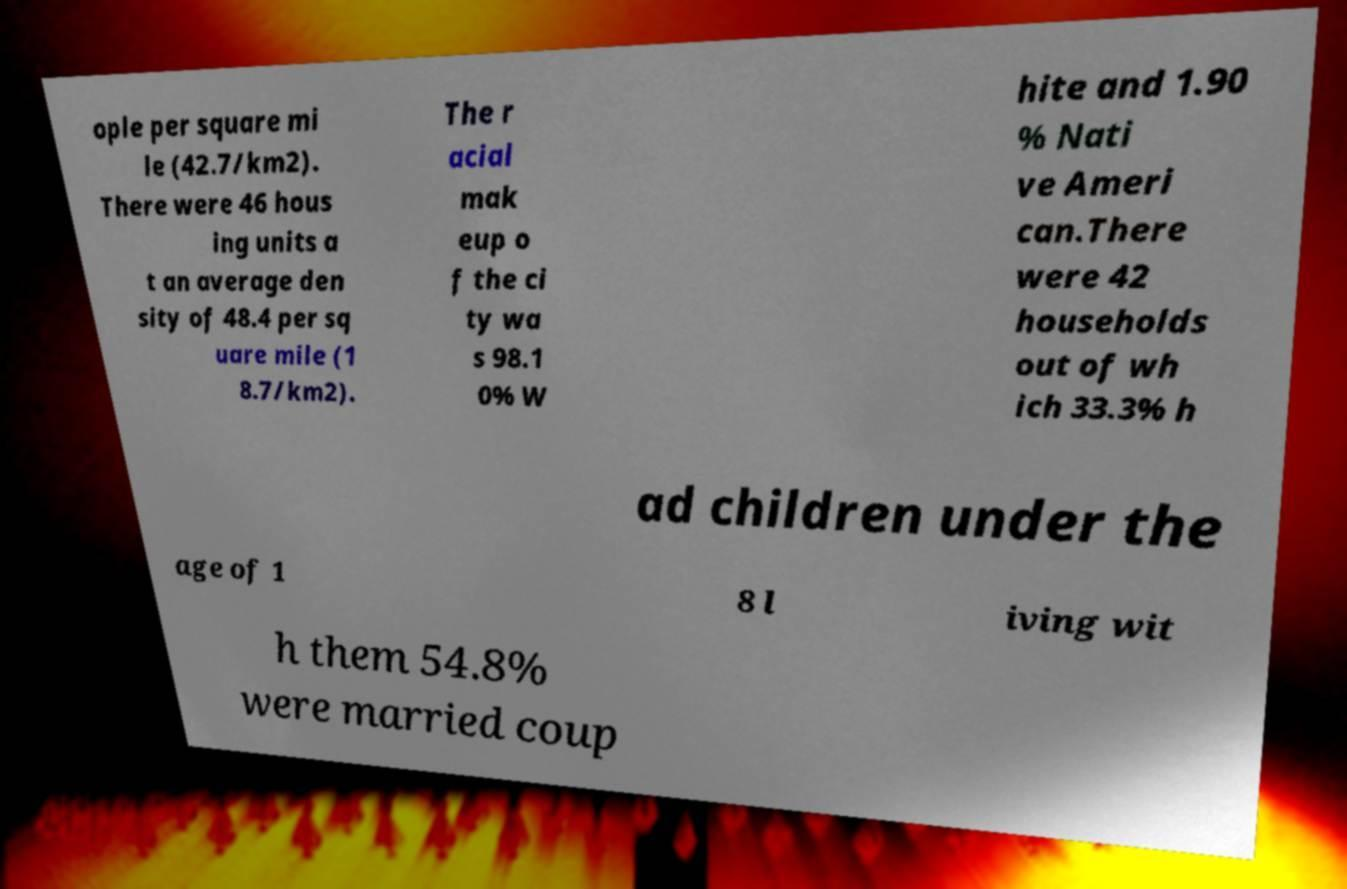For documentation purposes, I need the text within this image transcribed. Could you provide that? ople per square mi le (42.7/km2). There were 46 hous ing units a t an average den sity of 48.4 per sq uare mile (1 8.7/km2). The r acial mak eup o f the ci ty wa s 98.1 0% W hite and 1.90 % Nati ve Ameri can.There were 42 households out of wh ich 33.3% h ad children under the age of 1 8 l iving wit h them 54.8% were married coup 